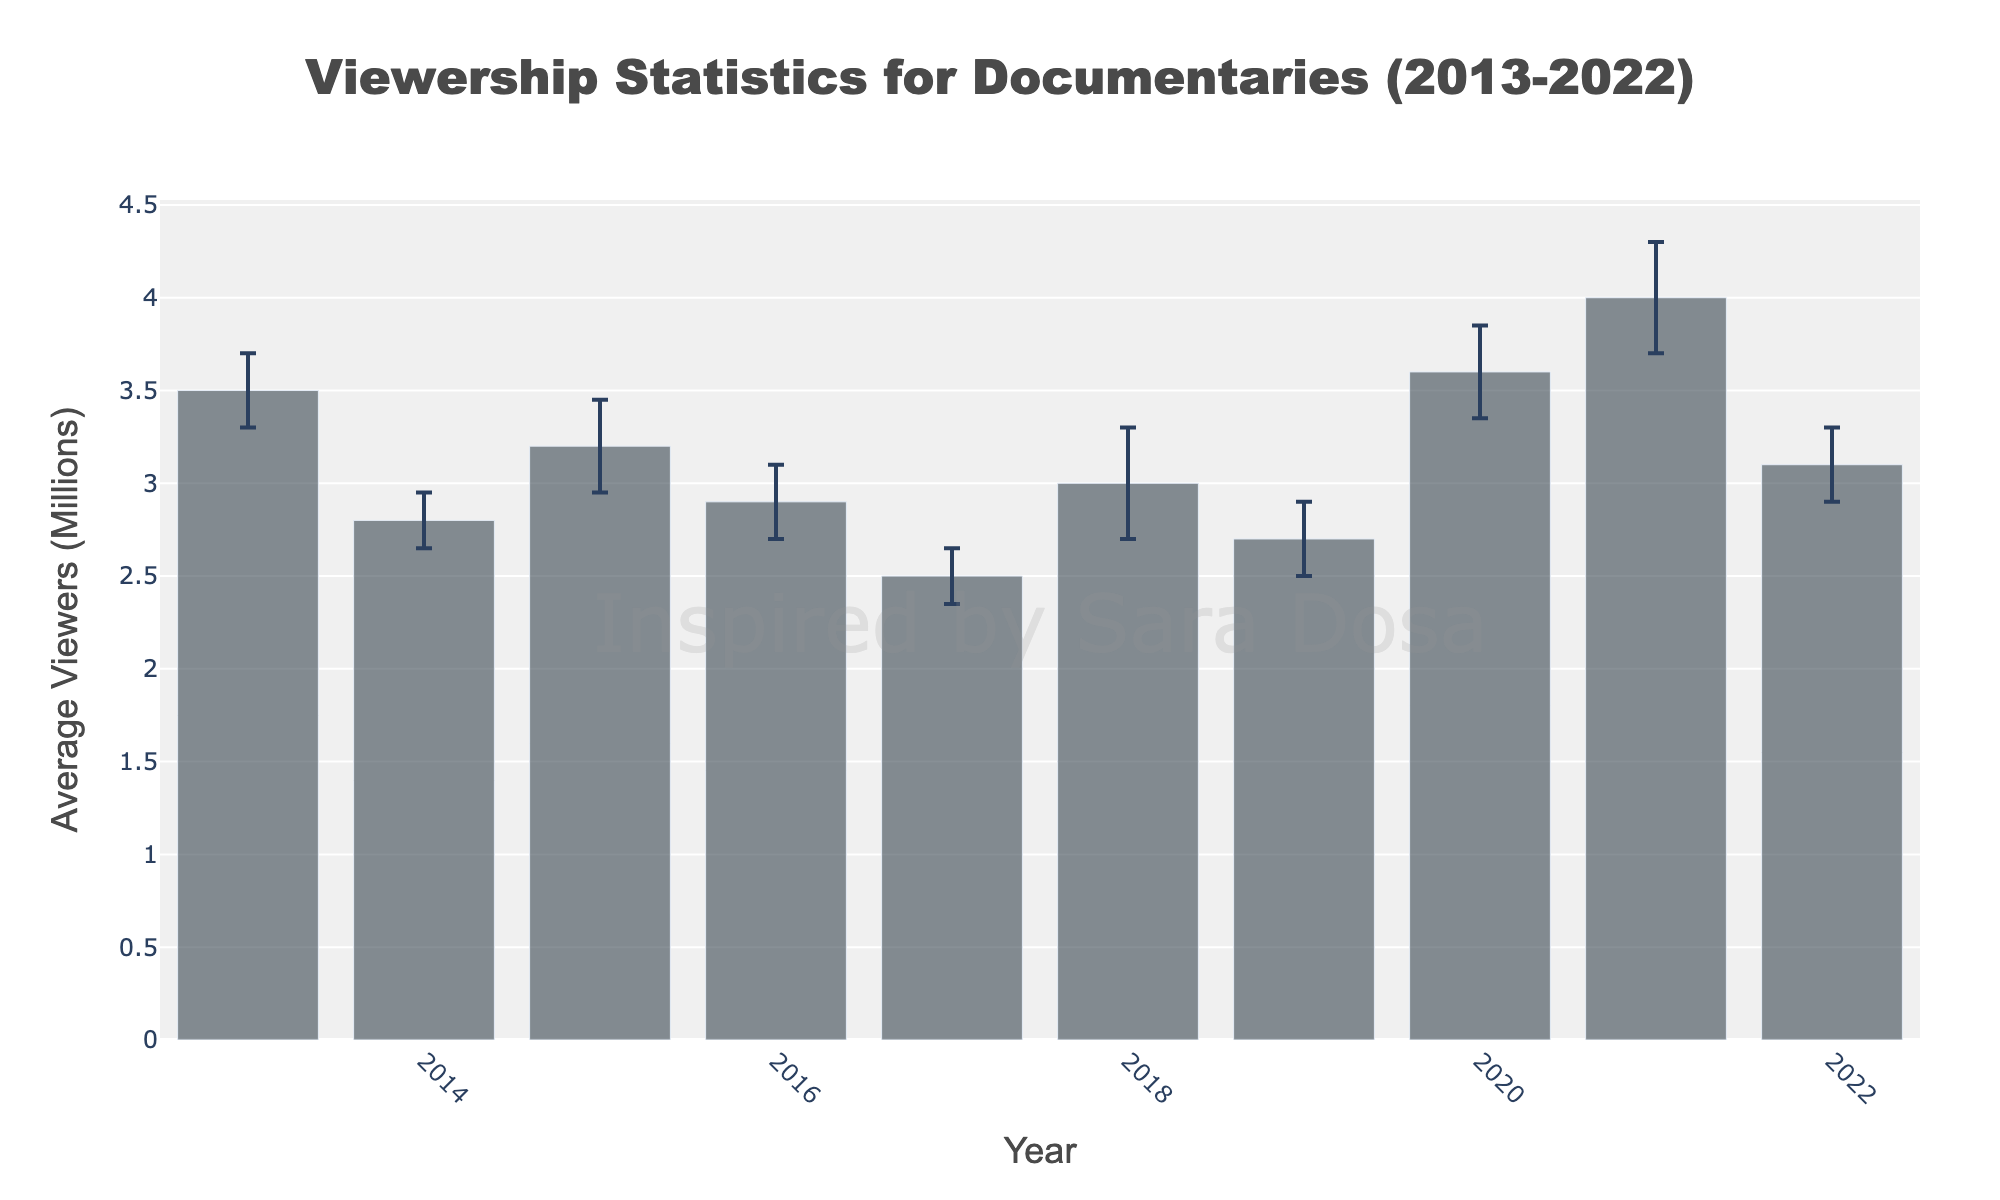What's the title of the figure? The title is typically displayed at the top of the figure.
Answer: Viewership Statistics for Documentaries (2013-2022) Which documentary had the highest average viewership? To find the documentary with the highest average viewership, look for the tallest bar in the chart.
Answer: The Social Dilemma Which year had the lowest average viewership, and what was the documentary for that year? Identify the shortest bar on the chart and check the year associated with it, then note the documentary from the hovertext.
Answer: 2017, Icarus What's the average margin of error across all documentaries? Add the margins of error together and divide by the number of documentaries. (0.2+0.15+0.25+0.2+0.15+0.3+0.2+0.25+0.3+0.2)/10 = 2/10
Answer: 0.2 Which documentaries had error bars that extend beyond the 3 million viewers mark? Find the documentaries where the error bars' upper limit exceeds 3 million viewers. This happens by checking the bar value plus the margin of error. For example, Blackfish's 3.5 + 0.2 > 3, and so on.
Answer: Blackfish, Three Identical Strangers, My Octopus Teacher, The Social Dilemma, Fire of Love Which documentary has the smallest margin of error and in what year was it released? Find the smallest error bar on the chart and note the documentary and its release year.
Answer: Citizenfour, 2014 What was the total viewership for the documentaries released in 2018 and 2022 combined? Add the viewership numbers for the documentaries released in those years. Three Identical Strangers (2018) had 3.0 million viewers, and Fire of Love (2022) had 3.1 million viewers. 3.0 + 3.1 = 6.1
Answer: 6.1 million How does the viewership of '13th' compare to 'American Factory'? Check the heights of '13th' and 'American Factory' bars to compare their average viewership. '13th' has 2.9 million viewers, while 'American Factory' has 2.7 million.
Answer: 13th has higher viewership Which documentaries were released between 2015 and 2019 and what were their viewership figures? Look at the documentaries released between those years and note their viewership data. The documentaries are Amy (3.2 million), 13th (2.9 million), Icarus (2.5 million), Three Identical Strangers (3.0 million), and American Factory (2.7 million).
Answer: Amy - 3.2 million, 13th - 2.9 million, Icarus - 2.5 million, Three Identical Strangers - 3.0 million, American Factory - 2.7 million 